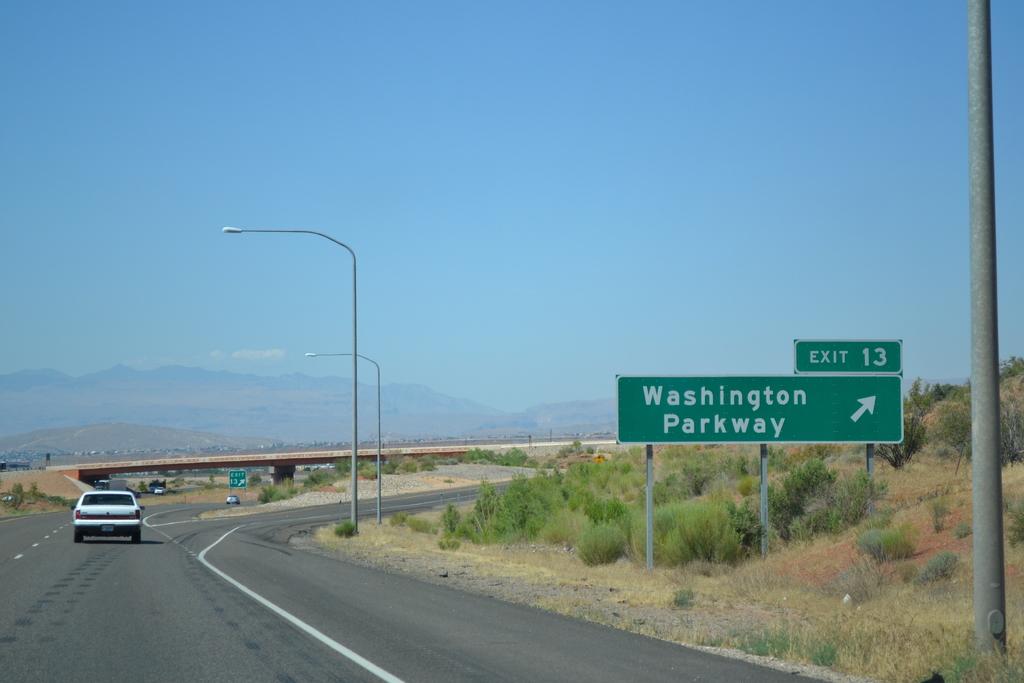What is the exit number?
Give a very brief answer. 13. 